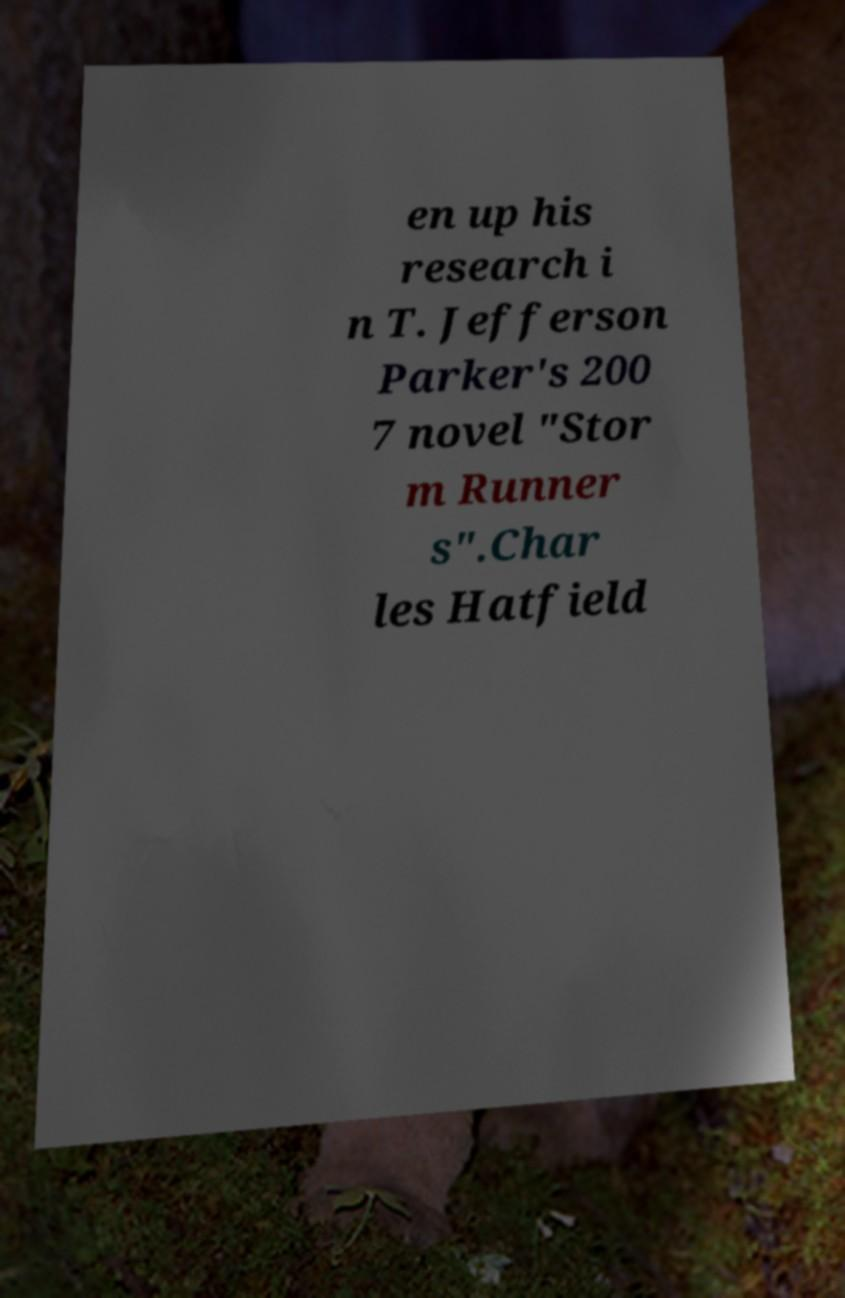I need the written content from this picture converted into text. Can you do that? en up his research i n T. Jefferson Parker's 200 7 novel "Stor m Runner s".Char les Hatfield 